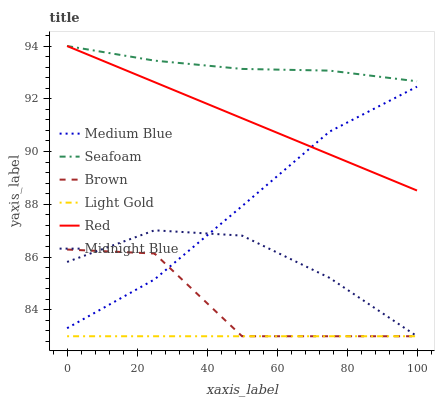Does Light Gold have the minimum area under the curve?
Answer yes or no. Yes. Does Seafoam have the maximum area under the curve?
Answer yes or no. Yes. Does Midnight Blue have the minimum area under the curve?
Answer yes or no. No. Does Midnight Blue have the maximum area under the curve?
Answer yes or no. No. Is Light Gold the smoothest?
Answer yes or no. Yes. Is Brown the roughest?
Answer yes or no. Yes. Is Midnight Blue the smoothest?
Answer yes or no. No. Is Midnight Blue the roughest?
Answer yes or no. No. Does Brown have the lowest value?
Answer yes or no. Yes. Does Medium Blue have the lowest value?
Answer yes or no. No. Does Red have the highest value?
Answer yes or no. Yes. Does Midnight Blue have the highest value?
Answer yes or no. No. Is Light Gold less than Red?
Answer yes or no. Yes. Is Red greater than Brown?
Answer yes or no. Yes. Does Seafoam intersect Red?
Answer yes or no. Yes. Is Seafoam less than Red?
Answer yes or no. No. Is Seafoam greater than Red?
Answer yes or no. No. Does Light Gold intersect Red?
Answer yes or no. No. 